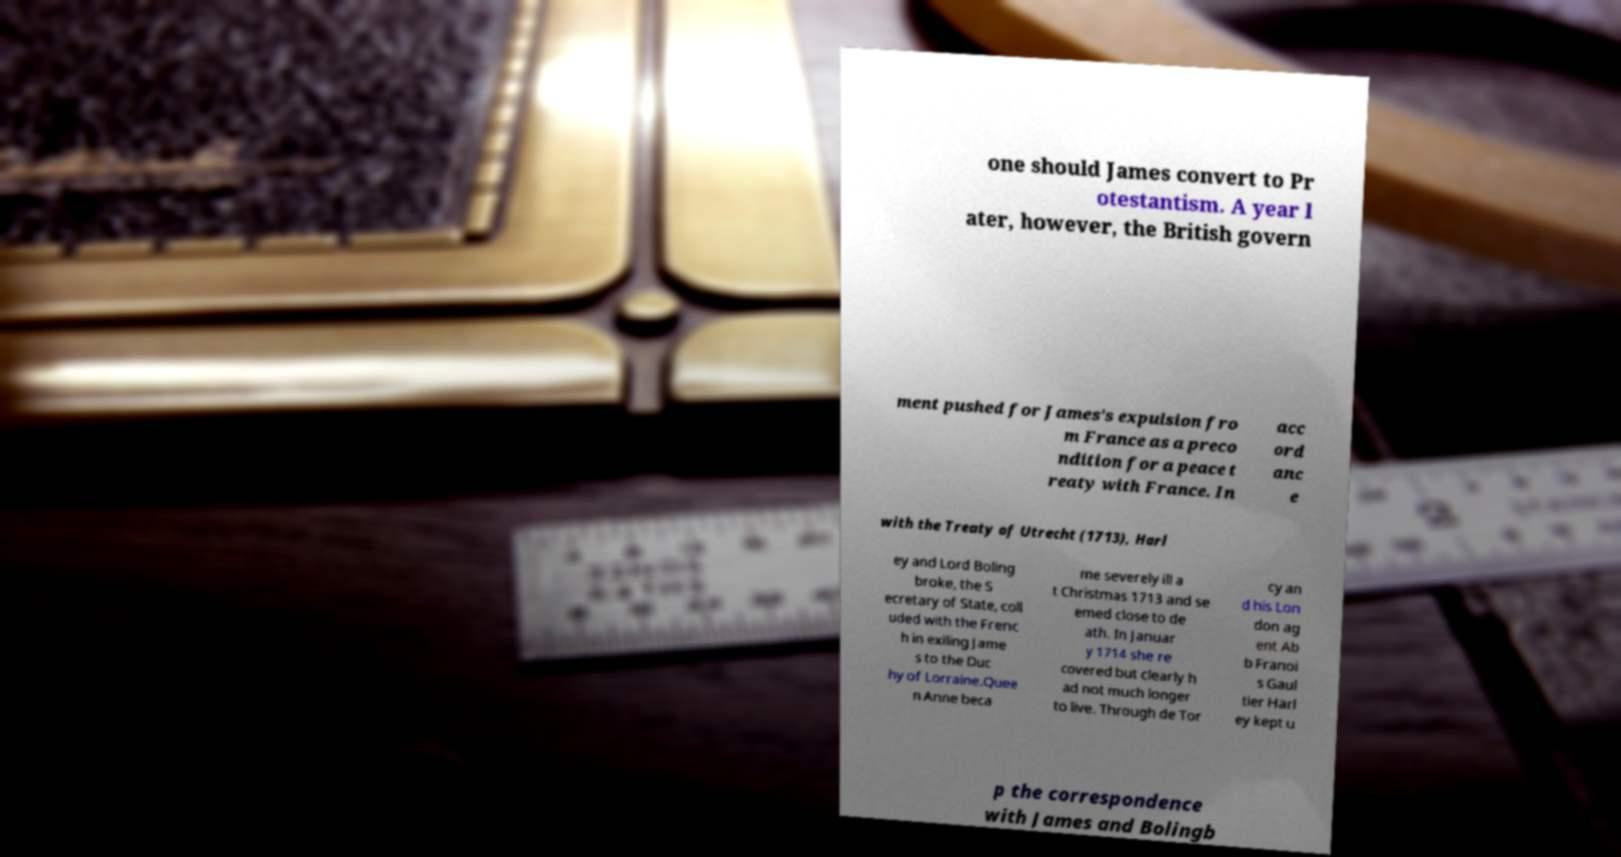Could you assist in decoding the text presented in this image and type it out clearly? one should James convert to Pr otestantism. A year l ater, however, the British govern ment pushed for James's expulsion fro m France as a preco ndition for a peace t reaty with France. In acc ord anc e with the Treaty of Utrecht (1713), Harl ey and Lord Boling broke, the S ecretary of State, coll uded with the Frenc h in exiling Jame s to the Duc hy of Lorraine.Quee n Anne beca me severely ill a t Christmas 1713 and se emed close to de ath. In Januar y 1714 she re covered but clearly h ad not much longer to live. Through de Tor cy an d his Lon don ag ent Ab b Franoi s Gaul tier Harl ey kept u p the correspondence with James and Bolingb 